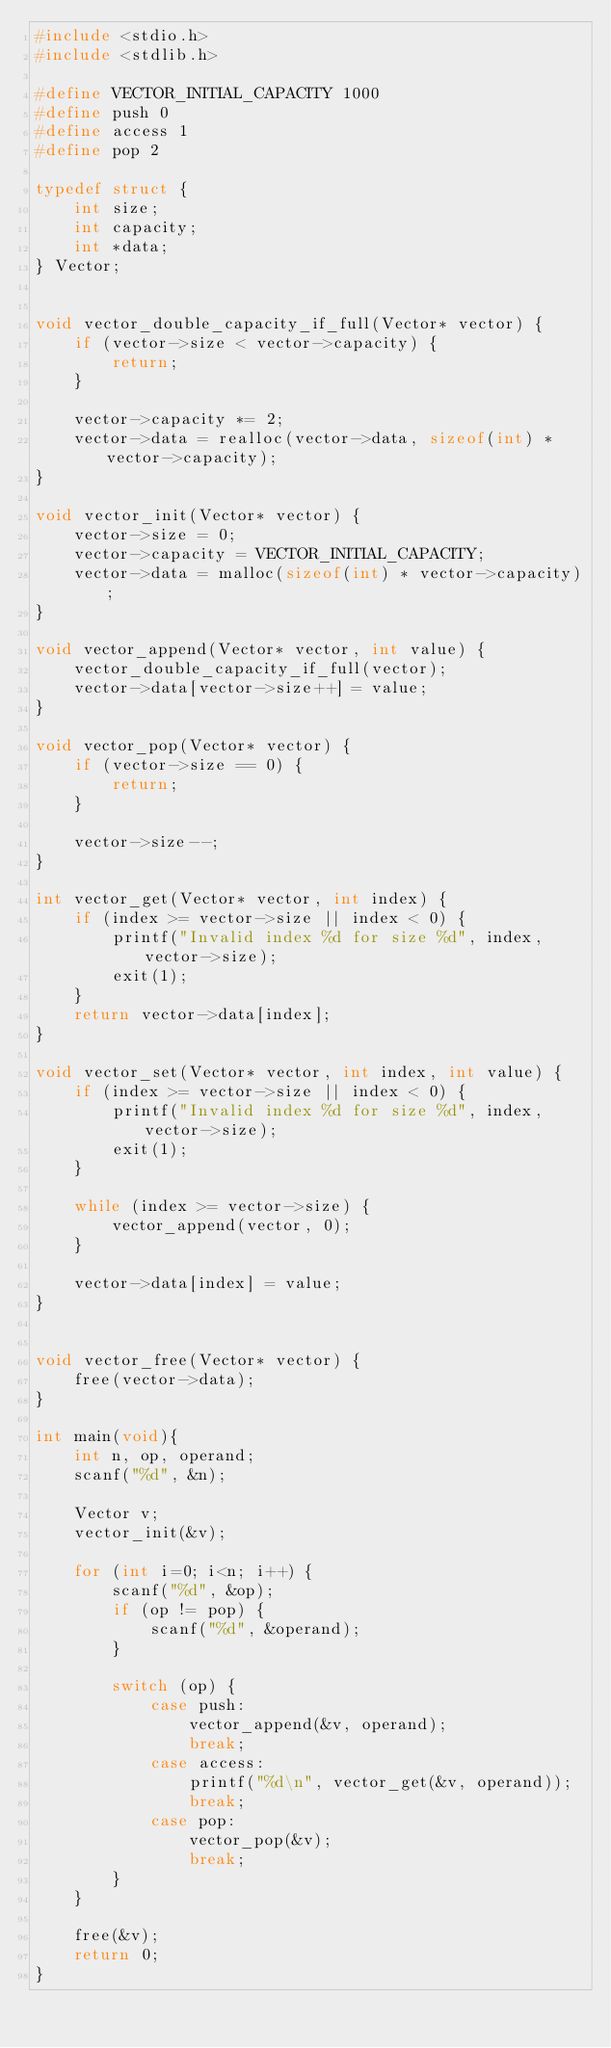<code> <loc_0><loc_0><loc_500><loc_500><_C_>#include <stdio.h>
#include <stdlib.h>

#define VECTOR_INITIAL_CAPACITY 1000
#define push 0
#define access 1
#define pop 2

typedef struct {
    int size;
    int capacity;
    int *data;
} Vector;


void vector_double_capacity_if_full(Vector* vector) {
    if (vector->size < vector->capacity) {
        return;
    }
    
    vector->capacity *= 2;
    vector->data = realloc(vector->data, sizeof(int) * vector->capacity);
}

void vector_init(Vector* vector) {
    vector->size = 0;
    vector->capacity = VECTOR_INITIAL_CAPACITY;
    vector->data = malloc(sizeof(int) * vector->capacity);
}

void vector_append(Vector* vector, int value) {
    vector_double_capacity_if_full(vector);
    vector->data[vector->size++] = value;
}

void vector_pop(Vector* vector) {
    if (vector->size == 0) {
        return;
    }
    
    vector->size--;
}

int vector_get(Vector* vector, int index) {
    if (index >= vector->size || index < 0) {
        printf("Invalid index %d for size %d", index, vector->size);
        exit(1);
    }
    return vector->data[index];
}

void vector_set(Vector* vector, int index, int value) {
    if (index >= vector->size || index < 0) {
        printf("Invalid index %d for size %d", index, vector->size);
        exit(1);
    }
    
    while (index >= vector->size) {
        vector_append(vector, 0);
    }
    
    vector->data[index] = value;
}


void vector_free(Vector* vector) {
    free(vector->data);
}

int main(void){
    int n, op, operand;
    scanf("%d", &n);
    
    Vector v;
    vector_init(&v);
    
    for (int i=0; i<n; i++) {
        scanf("%d", &op);
        if (op != pop) {
            scanf("%d", &operand);
        }

        switch (op) {
            case push:
                vector_append(&v, operand);
                break;
            case access:
                printf("%d\n", vector_get(&v, operand));
                break;
            case pop:
                vector_pop(&v);
                break;
        }
    }
    
    free(&v);
    return 0;
}

</code> 